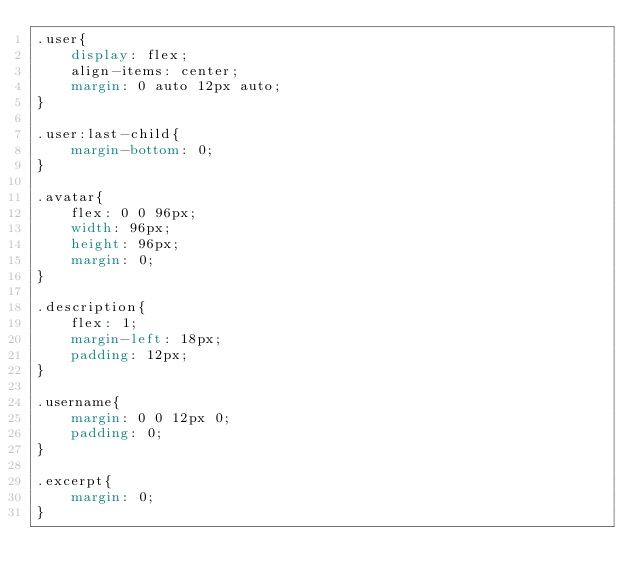<code> <loc_0><loc_0><loc_500><loc_500><_CSS_>.user{
    display: flex;
    align-items: center;
    margin: 0 auto 12px auto;
}

.user:last-child{
    margin-bottom: 0;
}

.avatar{
    flex: 0 0 96px;
    width: 96px;
    height: 96px;
    margin: 0;
}

.description{
    flex: 1;
    margin-left: 18px;
    padding: 12px;
}

.username{
    margin: 0 0 12px 0;
    padding: 0;
}

.excerpt{
    margin: 0;
}
</code> 